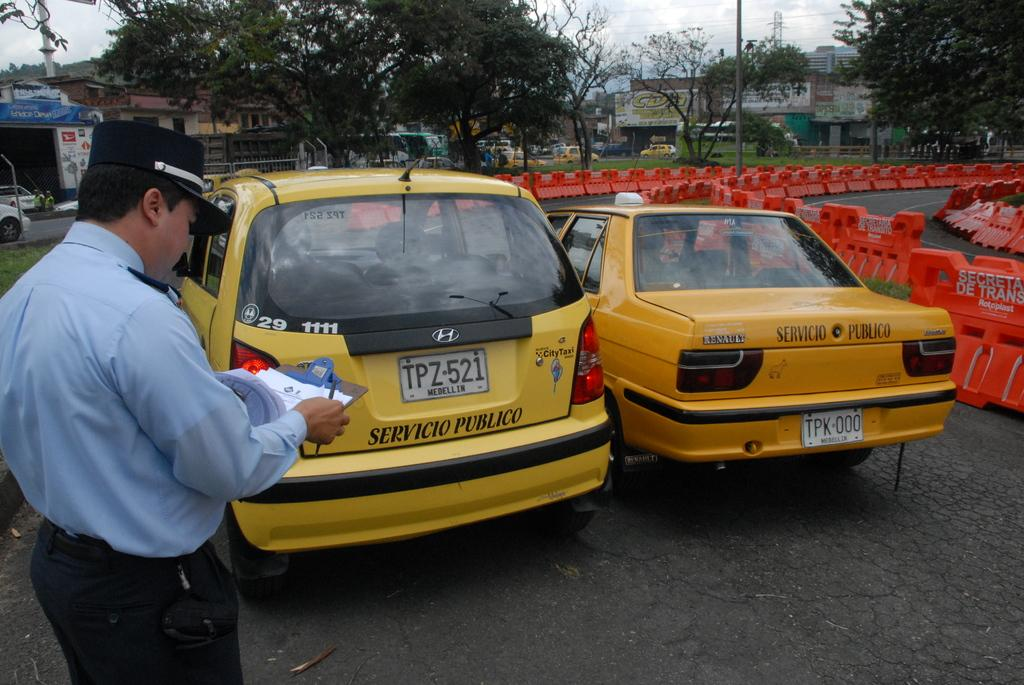<image>
Provide a brief description of the given image. An officer is writing on a clipboard by a yellow taxi that says Servicio Publico on the back. 